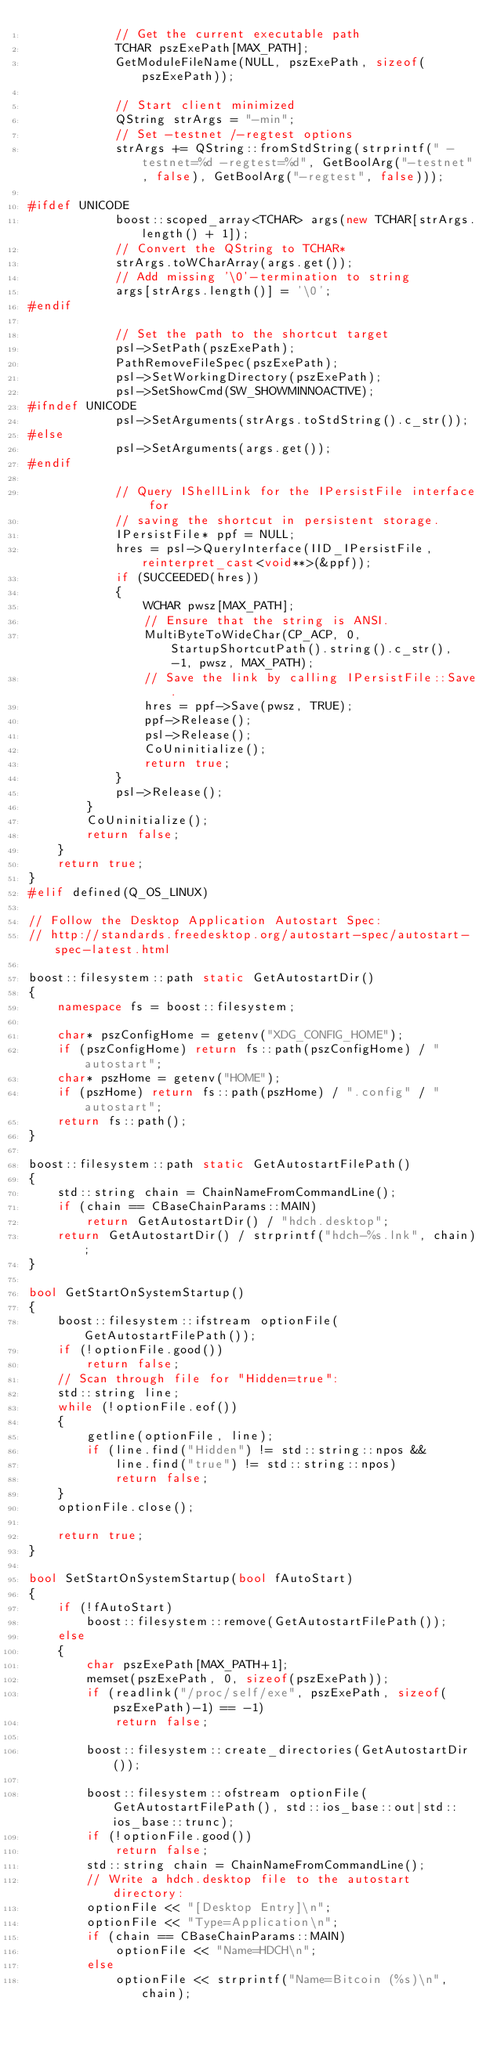<code> <loc_0><loc_0><loc_500><loc_500><_C++_>            // Get the current executable path
            TCHAR pszExePath[MAX_PATH];
            GetModuleFileName(NULL, pszExePath, sizeof(pszExePath));

            // Start client minimized
            QString strArgs = "-min";
            // Set -testnet /-regtest options
            strArgs += QString::fromStdString(strprintf(" -testnet=%d -regtest=%d", GetBoolArg("-testnet", false), GetBoolArg("-regtest", false)));

#ifdef UNICODE
            boost::scoped_array<TCHAR> args(new TCHAR[strArgs.length() + 1]);
            // Convert the QString to TCHAR*
            strArgs.toWCharArray(args.get());
            // Add missing '\0'-termination to string
            args[strArgs.length()] = '\0';
#endif

            // Set the path to the shortcut target
            psl->SetPath(pszExePath);
            PathRemoveFileSpec(pszExePath);
            psl->SetWorkingDirectory(pszExePath);
            psl->SetShowCmd(SW_SHOWMINNOACTIVE);
#ifndef UNICODE
            psl->SetArguments(strArgs.toStdString().c_str());
#else
            psl->SetArguments(args.get());
#endif

            // Query IShellLink for the IPersistFile interface for
            // saving the shortcut in persistent storage.
            IPersistFile* ppf = NULL;
            hres = psl->QueryInterface(IID_IPersistFile, reinterpret_cast<void**>(&ppf));
            if (SUCCEEDED(hres))
            {
                WCHAR pwsz[MAX_PATH];
                // Ensure that the string is ANSI.
                MultiByteToWideChar(CP_ACP, 0, StartupShortcutPath().string().c_str(), -1, pwsz, MAX_PATH);
                // Save the link by calling IPersistFile::Save.
                hres = ppf->Save(pwsz, TRUE);
                ppf->Release();
                psl->Release();
                CoUninitialize();
                return true;
            }
            psl->Release();
        }
        CoUninitialize();
        return false;
    }
    return true;
}
#elif defined(Q_OS_LINUX)

// Follow the Desktop Application Autostart Spec:
// http://standards.freedesktop.org/autostart-spec/autostart-spec-latest.html

boost::filesystem::path static GetAutostartDir()
{
    namespace fs = boost::filesystem;

    char* pszConfigHome = getenv("XDG_CONFIG_HOME");
    if (pszConfigHome) return fs::path(pszConfigHome) / "autostart";
    char* pszHome = getenv("HOME");
    if (pszHome) return fs::path(pszHome) / ".config" / "autostart";
    return fs::path();
}

boost::filesystem::path static GetAutostartFilePath()
{
    std::string chain = ChainNameFromCommandLine();
    if (chain == CBaseChainParams::MAIN)
        return GetAutostartDir() / "hdch.desktop";
    return GetAutostartDir() / strprintf("hdch-%s.lnk", chain);
}

bool GetStartOnSystemStartup()
{
    boost::filesystem::ifstream optionFile(GetAutostartFilePath());
    if (!optionFile.good())
        return false;
    // Scan through file for "Hidden=true":
    std::string line;
    while (!optionFile.eof())
    {
        getline(optionFile, line);
        if (line.find("Hidden") != std::string::npos &&
            line.find("true") != std::string::npos)
            return false;
    }
    optionFile.close();

    return true;
}

bool SetStartOnSystemStartup(bool fAutoStart)
{
    if (!fAutoStart)
        boost::filesystem::remove(GetAutostartFilePath());
    else
    {
        char pszExePath[MAX_PATH+1];
        memset(pszExePath, 0, sizeof(pszExePath));
        if (readlink("/proc/self/exe", pszExePath, sizeof(pszExePath)-1) == -1)
            return false;

        boost::filesystem::create_directories(GetAutostartDir());

        boost::filesystem::ofstream optionFile(GetAutostartFilePath(), std::ios_base::out|std::ios_base::trunc);
        if (!optionFile.good())
            return false;
        std::string chain = ChainNameFromCommandLine();
        // Write a hdch.desktop file to the autostart directory:
        optionFile << "[Desktop Entry]\n";
        optionFile << "Type=Application\n";
        if (chain == CBaseChainParams::MAIN)
            optionFile << "Name=HDCH\n";
        else
            optionFile << strprintf("Name=Bitcoin (%s)\n", chain);</code> 